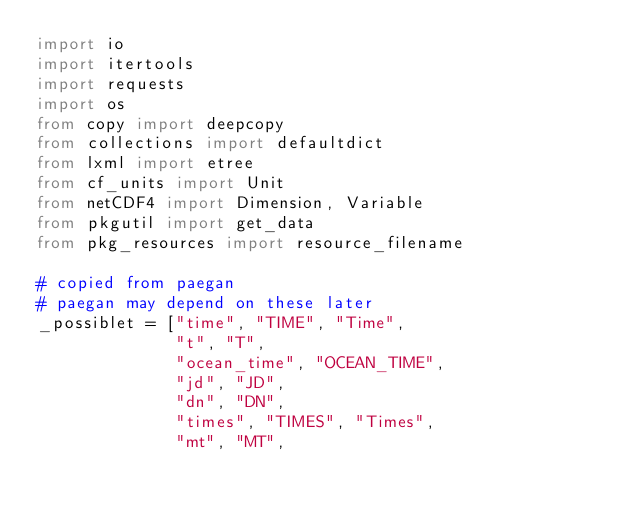Convert code to text. <code><loc_0><loc_0><loc_500><loc_500><_Python_>import io
import itertools
import requests
import os
from copy import deepcopy
from collections import defaultdict
from lxml import etree
from cf_units import Unit
from netCDF4 import Dimension, Variable
from pkgutil import get_data
from pkg_resources import resource_filename

# copied from paegan
# paegan may depend on these later
_possiblet = ["time", "TIME", "Time",
              "t", "T",
              "ocean_time", "OCEAN_TIME",
              "jd", "JD",
              "dn", "DN",
              "times", "TIMES", "Times",
              "mt", "MT",</code> 